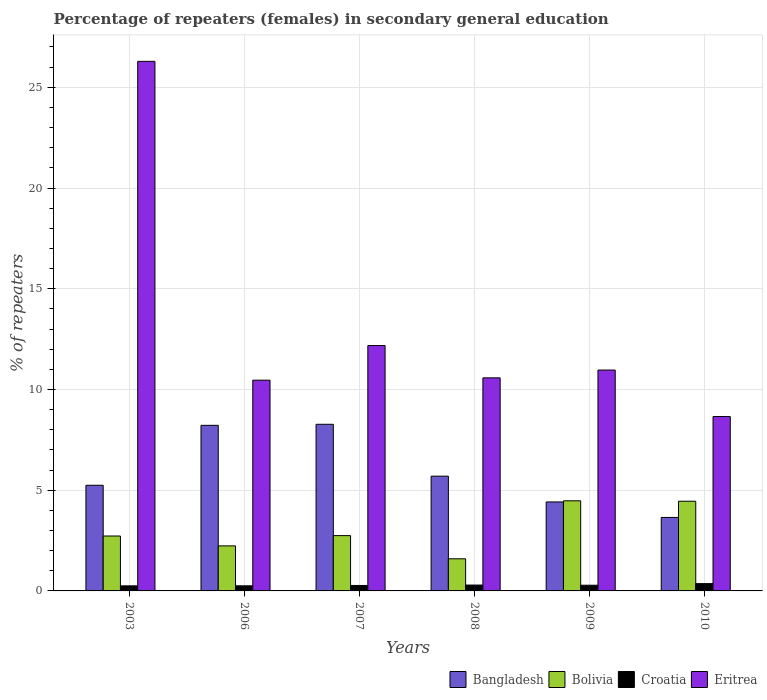How many groups of bars are there?
Keep it short and to the point. 6. Are the number of bars on each tick of the X-axis equal?
Offer a terse response. Yes. What is the label of the 5th group of bars from the left?
Make the answer very short. 2009. What is the percentage of female repeaters in Bolivia in 2009?
Ensure brevity in your answer.  4.47. Across all years, what is the maximum percentage of female repeaters in Croatia?
Keep it short and to the point. 0.36. Across all years, what is the minimum percentage of female repeaters in Croatia?
Provide a succinct answer. 0.25. What is the total percentage of female repeaters in Bolivia in the graph?
Ensure brevity in your answer.  18.23. What is the difference between the percentage of female repeaters in Bolivia in 2006 and that in 2008?
Keep it short and to the point. 0.64. What is the difference between the percentage of female repeaters in Bolivia in 2010 and the percentage of female repeaters in Bangladesh in 2003?
Offer a very short reply. -0.79. What is the average percentage of female repeaters in Bangladesh per year?
Your response must be concise. 5.92. In the year 2006, what is the difference between the percentage of female repeaters in Eritrea and percentage of female repeaters in Bolivia?
Offer a terse response. 8.23. What is the ratio of the percentage of female repeaters in Eritrea in 2008 to that in 2009?
Provide a short and direct response. 0.96. What is the difference between the highest and the second highest percentage of female repeaters in Eritrea?
Offer a very short reply. 14.11. What is the difference between the highest and the lowest percentage of female repeaters in Croatia?
Give a very brief answer. 0.11. Is the sum of the percentage of female repeaters in Bolivia in 2006 and 2009 greater than the maximum percentage of female repeaters in Bangladesh across all years?
Provide a short and direct response. No. What does the 3rd bar from the left in 2009 represents?
Your response must be concise. Croatia. Does the graph contain any zero values?
Your response must be concise. No. How many legend labels are there?
Your response must be concise. 4. How are the legend labels stacked?
Give a very brief answer. Horizontal. What is the title of the graph?
Give a very brief answer. Percentage of repeaters (females) in secondary general education. What is the label or title of the Y-axis?
Provide a short and direct response. % of repeaters. What is the % of repeaters in Bangladesh in 2003?
Your answer should be compact. 5.24. What is the % of repeaters of Bolivia in 2003?
Make the answer very short. 2.73. What is the % of repeaters in Croatia in 2003?
Give a very brief answer. 0.25. What is the % of repeaters in Eritrea in 2003?
Provide a succinct answer. 26.29. What is the % of repeaters of Bangladesh in 2006?
Keep it short and to the point. 8.22. What is the % of repeaters in Bolivia in 2006?
Ensure brevity in your answer.  2.24. What is the % of repeaters in Croatia in 2006?
Your answer should be compact. 0.25. What is the % of repeaters of Eritrea in 2006?
Your answer should be compact. 10.46. What is the % of repeaters of Bangladesh in 2007?
Keep it short and to the point. 8.27. What is the % of repeaters of Bolivia in 2007?
Offer a terse response. 2.75. What is the % of repeaters of Croatia in 2007?
Your answer should be compact. 0.27. What is the % of repeaters in Eritrea in 2007?
Provide a short and direct response. 12.18. What is the % of repeaters of Bangladesh in 2008?
Your answer should be compact. 5.7. What is the % of repeaters in Bolivia in 2008?
Provide a succinct answer. 1.6. What is the % of repeaters in Croatia in 2008?
Ensure brevity in your answer.  0.29. What is the % of repeaters of Eritrea in 2008?
Provide a succinct answer. 10.58. What is the % of repeaters of Bangladesh in 2009?
Offer a terse response. 4.42. What is the % of repeaters in Bolivia in 2009?
Offer a terse response. 4.47. What is the % of repeaters of Croatia in 2009?
Make the answer very short. 0.28. What is the % of repeaters of Eritrea in 2009?
Keep it short and to the point. 10.96. What is the % of repeaters of Bangladesh in 2010?
Provide a succinct answer. 3.65. What is the % of repeaters of Bolivia in 2010?
Your answer should be very brief. 4.45. What is the % of repeaters of Croatia in 2010?
Your answer should be very brief. 0.36. What is the % of repeaters of Eritrea in 2010?
Keep it short and to the point. 8.66. Across all years, what is the maximum % of repeaters in Bangladesh?
Offer a very short reply. 8.27. Across all years, what is the maximum % of repeaters in Bolivia?
Give a very brief answer. 4.47. Across all years, what is the maximum % of repeaters of Croatia?
Your answer should be very brief. 0.36. Across all years, what is the maximum % of repeaters of Eritrea?
Make the answer very short. 26.29. Across all years, what is the minimum % of repeaters of Bangladesh?
Provide a short and direct response. 3.65. Across all years, what is the minimum % of repeaters of Bolivia?
Your response must be concise. 1.6. Across all years, what is the minimum % of repeaters of Croatia?
Keep it short and to the point. 0.25. Across all years, what is the minimum % of repeaters in Eritrea?
Your answer should be very brief. 8.66. What is the total % of repeaters in Bangladesh in the graph?
Ensure brevity in your answer.  35.5. What is the total % of repeaters in Bolivia in the graph?
Keep it short and to the point. 18.23. What is the total % of repeaters in Croatia in the graph?
Ensure brevity in your answer.  1.71. What is the total % of repeaters of Eritrea in the graph?
Give a very brief answer. 79.12. What is the difference between the % of repeaters in Bangladesh in 2003 and that in 2006?
Give a very brief answer. -2.98. What is the difference between the % of repeaters in Bolivia in 2003 and that in 2006?
Your answer should be compact. 0.49. What is the difference between the % of repeaters in Croatia in 2003 and that in 2006?
Your answer should be compact. -0. What is the difference between the % of repeaters in Eritrea in 2003 and that in 2006?
Give a very brief answer. 15.83. What is the difference between the % of repeaters in Bangladesh in 2003 and that in 2007?
Offer a very short reply. -3.03. What is the difference between the % of repeaters of Bolivia in 2003 and that in 2007?
Keep it short and to the point. -0.02. What is the difference between the % of repeaters in Croatia in 2003 and that in 2007?
Keep it short and to the point. -0.02. What is the difference between the % of repeaters of Eritrea in 2003 and that in 2007?
Keep it short and to the point. 14.11. What is the difference between the % of repeaters of Bangladesh in 2003 and that in 2008?
Your answer should be compact. -0.45. What is the difference between the % of repeaters of Bolivia in 2003 and that in 2008?
Give a very brief answer. 1.13. What is the difference between the % of repeaters of Croatia in 2003 and that in 2008?
Your response must be concise. -0.04. What is the difference between the % of repeaters in Eritrea in 2003 and that in 2008?
Offer a terse response. 15.71. What is the difference between the % of repeaters of Bangladesh in 2003 and that in 2009?
Offer a very short reply. 0.83. What is the difference between the % of repeaters in Bolivia in 2003 and that in 2009?
Make the answer very short. -1.75. What is the difference between the % of repeaters in Croatia in 2003 and that in 2009?
Your response must be concise. -0.03. What is the difference between the % of repeaters in Eritrea in 2003 and that in 2009?
Provide a succinct answer. 15.32. What is the difference between the % of repeaters of Bangladesh in 2003 and that in 2010?
Ensure brevity in your answer.  1.6. What is the difference between the % of repeaters of Bolivia in 2003 and that in 2010?
Keep it short and to the point. -1.73. What is the difference between the % of repeaters in Croatia in 2003 and that in 2010?
Provide a short and direct response. -0.11. What is the difference between the % of repeaters in Eritrea in 2003 and that in 2010?
Your answer should be compact. 17.63. What is the difference between the % of repeaters of Bangladesh in 2006 and that in 2007?
Make the answer very short. -0.05. What is the difference between the % of repeaters in Bolivia in 2006 and that in 2007?
Your response must be concise. -0.51. What is the difference between the % of repeaters of Croatia in 2006 and that in 2007?
Ensure brevity in your answer.  -0.02. What is the difference between the % of repeaters in Eritrea in 2006 and that in 2007?
Your response must be concise. -1.72. What is the difference between the % of repeaters of Bangladesh in 2006 and that in 2008?
Your answer should be compact. 2.52. What is the difference between the % of repeaters in Bolivia in 2006 and that in 2008?
Offer a terse response. 0.64. What is the difference between the % of repeaters in Croatia in 2006 and that in 2008?
Offer a very short reply. -0.04. What is the difference between the % of repeaters in Eritrea in 2006 and that in 2008?
Ensure brevity in your answer.  -0.11. What is the difference between the % of repeaters of Bangladesh in 2006 and that in 2009?
Your response must be concise. 3.8. What is the difference between the % of repeaters in Bolivia in 2006 and that in 2009?
Provide a succinct answer. -2.24. What is the difference between the % of repeaters in Croatia in 2006 and that in 2009?
Ensure brevity in your answer.  -0.03. What is the difference between the % of repeaters of Eritrea in 2006 and that in 2009?
Your answer should be very brief. -0.5. What is the difference between the % of repeaters in Bangladesh in 2006 and that in 2010?
Keep it short and to the point. 4.57. What is the difference between the % of repeaters of Bolivia in 2006 and that in 2010?
Offer a very short reply. -2.22. What is the difference between the % of repeaters of Croatia in 2006 and that in 2010?
Give a very brief answer. -0.11. What is the difference between the % of repeaters in Eritrea in 2006 and that in 2010?
Your answer should be compact. 1.8. What is the difference between the % of repeaters of Bangladesh in 2007 and that in 2008?
Make the answer very short. 2.57. What is the difference between the % of repeaters in Bolivia in 2007 and that in 2008?
Your answer should be compact. 1.15. What is the difference between the % of repeaters in Croatia in 2007 and that in 2008?
Your answer should be very brief. -0.02. What is the difference between the % of repeaters in Eritrea in 2007 and that in 2008?
Make the answer very short. 1.6. What is the difference between the % of repeaters in Bangladesh in 2007 and that in 2009?
Offer a terse response. 3.85. What is the difference between the % of repeaters in Bolivia in 2007 and that in 2009?
Ensure brevity in your answer.  -1.73. What is the difference between the % of repeaters of Croatia in 2007 and that in 2009?
Your response must be concise. -0.01. What is the difference between the % of repeaters of Eritrea in 2007 and that in 2009?
Keep it short and to the point. 1.22. What is the difference between the % of repeaters in Bangladesh in 2007 and that in 2010?
Ensure brevity in your answer.  4.62. What is the difference between the % of repeaters in Bolivia in 2007 and that in 2010?
Provide a short and direct response. -1.71. What is the difference between the % of repeaters in Croatia in 2007 and that in 2010?
Ensure brevity in your answer.  -0.09. What is the difference between the % of repeaters in Eritrea in 2007 and that in 2010?
Give a very brief answer. 3.52. What is the difference between the % of repeaters of Bangladesh in 2008 and that in 2009?
Offer a very short reply. 1.28. What is the difference between the % of repeaters of Bolivia in 2008 and that in 2009?
Provide a succinct answer. -2.88. What is the difference between the % of repeaters in Croatia in 2008 and that in 2009?
Your answer should be very brief. 0.01. What is the difference between the % of repeaters in Eritrea in 2008 and that in 2009?
Your answer should be compact. -0.39. What is the difference between the % of repeaters in Bangladesh in 2008 and that in 2010?
Your answer should be very brief. 2.05. What is the difference between the % of repeaters in Bolivia in 2008 and that in 2010?
Offer a terse response. -2.86. What is the difference between the % of repeaters of Croatia in 2008 and that in 2010?
Your answer should be compact. -0.07. What is the difference between the % of repeaters of Eritrea in 2008 and that in 2010?
Keep it short and to the point. 1.92. What is the difference between the % of repeaters in Bangladesh in 2009 and that in 2010?
Ensure brevity in your answer.  0.77. What is the difference between the % of repeaters of Bolivia in 2009 and that in 2010?
Offer a terse response. 0.02. What is the difference between the % of repeaters of Croatia in 2009 and that in 2010?
Provide a short and direct response. -0.08. What is the difference between the % of repeaters in Eritrea in 2009 and that in 2010?
Provide a succinct answer. 2.31. What is the difference between the % of repeaters in Bangladesh in 2003 and the % of repeaters in Bolivia in 2006?
Give a very brief answer. 3.01. What is the difference between the % of repeaters in Bangladesh in 2003 and the % of repeaters in Croatia in 2006?
Offer a very short reply. 4.99. What is the difference between the % of repeaters of Bangladesh in 2003 and the % of repeaters of Eritrea in 2006?
Provide a short and direct response. -5.22. What is the difference between the % of repeaters in Bolivia in 2003 and the % of repeaters in Croatia in 2006?
Offer a very short reply. 2.47. What is the difference between the % of repeaters of Bolivia in 2003 and the % of repeaters of Eritrea in 2006?
Make the answer very short. -7.74. What is the difference between the % of repeaters of Croatia in 2003 and the % of repeaters of Eritrea in 2006?
Keep it short and to the point. -10.21. What is the difference between the % of repeaters of Bangladesh in 2003 and the % of repeaters of Bolivia in 2007?
Provide a succinct answer. 2.5. What is the difference between the % of repeaters of Bangladesh in 2003 and the % of repeaters of Croatia in 2007?
Keep it short and to the point. 4.97. What is the difference between the % of repeaters in Bangladesh in 2003 and the % of repeaters in Eritrea in 2007?
Give a very brief answer. -6.93. What is the difference between the % of repeaters in Bolivia in 2003 and the % of repeaters in Croatia in 2007?
Your response must be concise. 2.45. What is the difference between the % of repeaters of Bolivia in 2003 and the % of repeaters of Eritrea in 2007?
Offer a terse response. -9.45. What is the difference between the % of repeaters in Croatia in 2003 and the % of repeaters in Eritrea in 2007?
Your answer should be very brief. -11.93. What is the difference between the % of repeaters of Bangladesh in 2003 and the % of repeaters of Bolivia in 2008?
Your answer should be very brief. 3.65. What is the difference between the % of repeaters of Bangladesh in 2003 and the % of repeaters of Croatia in 2008?
Ensure brevity in your answer.  4.95. What is the difference between the % of repeaters of Bangladesh in 2003 and the % of repeaters of Eritrea in 2008?
Keep it short and to the point. -5.33. What is the difference between the % of repeaters in Bolivia in 2003 and the % of repeaters in Croatia in 2008?
Your response must be concise. 2.43. What is the difference between the % of repeaters in Bolivia in 2003 and the % of repeaters in Eritrea in 2008?
Ensure brevity in your answer.  -7.85. What is the difference between the % of repeaters of Croatia in 2003 and the % of repeaters of Eritrea in 2008?
Offer a very short reply. -10.32. What is the difference between the % of repeaters of Bangladesh in 2003 and the % of repeaters of Bolivia in 2009?
Give a very brief answer. 0.77. What is the difference between the % of repeaters in Bangladesh in 2003 and the % of repeaters in Croatia in 2009?
Give a very brief answer. 4.96. What is the difference between the % of repeaters in Bangladesh in 2003 and the % of repeaters in Eritrea in 2009?
Provide a succinct answer. -5.72. What is the difference between the % of repeaters of Bolivia in 2003 and the % of repeaters of Croatia in 2009?
Offer a very short reply. 2.44. What is the difference between the % of repeaters in Bolivia in 2003 and the % of repeaters in Eritrea in 2009?
Your answer should be very brief. -8.24. What is the difference between the % of repeaters of Croatia in 2003 and the % of repeaters of Eritrea in 2009?
Your answer should be compact. -10.71. What is the difference between the % of repeaters of Bangladesh in 2003 and the % of repeaters of Bolivia in 2010?
Your answer should be very brief. 0.79. What is the difference between the % of repeaters of Bangladesh in 2003 and the % of repeaters of Croatia in 2010?
Provide a short and direct response. 4.88. What is the difference between the % of repeaters of Bangladesh in 2003 and the % of repeaters of Eritrea in 2010?
Your response must be concise. -3.41. What is the difference between the % of repeaters of Bolivia in 2003 and the % of repeaters of Croatia in 2010?
Ensure brevity in your answer.  2.36. What is the difference between the % of repeaters of Bolivia in 2003 and the % of repeaters of Eritrea in 2010?
Offer a terse response. -5.93. What is the difference between the % of repeaters in Croatia in 2003 and the % of repeaters in Eritrea in 2010?
Give a very brief answer. -8.41. What is the difference between the % of repeaters of Bangladesh in 2006 and the % of repeaters of Bolivia in 2007?
Your answer should be very brief. 5.47. What is the difference between the % of repeaters in Bangladesh in 2006 and the % of repeaters in Croatia in 2007?
Offer a terse response. 7.95. What is the difference between the % of repeaters in Bangladesh in 2006 and the % of repeaters in Eritrea in 2007?
Keep it short and to the point. -3.96. What is the difference between the % of repeaters in Bolivia in 2006 and the % of repeaters in Croatia in 2007?
Provide a succinct answer. 1.96. What is the difference between the % of repeaters of Bolivia in 2006 and the % of repeaters of Eritrea in 2007?
Provide a succinct answer. -9.94. What is the difference between the % of repeaters of Croatia in 2006 and the % of repeaters of Eritrea in 2007?
Make the answer very short. -11.93. What is the difference between the % of repeaters of Bangladesh in 2006 and the % of repeaters of Bolivia in 2008?
Make the answer very short. 6.62. What is the difference between the % of repeaters of Bangladesh in 2006 and the % of repeaters of Croatia in 2008?
Keep it short and to the point. 7.93. What is the difference between the % of repeaters of Bangladesh in 2006 and the % of repeaters of Eritrea in 2008?
Ensure brevity in your answer.  -2.36. What is the difference between the % of repeaters of Bolivia in 2006 and the % of repeaters of Croatia in 2008?
Keep it short and to the point. 1.94. What is the difference between the % of repeaters in Bolivia in 2006 and the % of repeaters in Eritrea in 2008?
Your answer should be compact. -8.34. What is the difference between the % of repeaters in Croatia in 2006 and the % of repeaters in Eritrea in 2008?
Ensure brevity in your answer.  -10.32. What is the difference between the % of repeaters of Bangladesh in 2006 and the % of repeaters of Bolivia in 2009?
Your answer should be very brief. 3.75. What is the difference between the % of repeaters in Bangladesh in 2006 and the % of repeaters in Croatia in 2009?
Offer a very short reply. 7.94. What is the difference between the % of repeaters in Bangladesh in 2006 and the % of repeaters in Eritrea in 2009?
Provide a short and direct response. -2.74. What is the difference between the % of repeaters of Bolivia in 2006 and the % of repeaters of Croatia in 2009?
Ensure brevity in your answer.  1.95. What is the difference between the % of repeaters in Bolivia in 2006 and the % of repeaters in Eritrea in 2009?
Make the answer very short. -8.73. What is the difference between the % of repeaters in Croatia in 2006 and the % of repeaters in Eritrea in 2009?
Offer a very short reply. -10.71. What is the difference between the % of repeaters in Bangladesh in 2006 and the % of repeaters in Bolivia in 2010?
Provide a succinct answer. 3.77. What is the difference between the % of repeaters in Bangladesh in 2006 and the % of repeaters in Croatia in 2010?
Ensure brevity in your answer.  7.86. What is the difference between the % of repeaters of Bangladesh in 2006 and the % of repeaters of Eritrea in 2010?
Provide a short and direct response. -0.44. What is the difference between the % of repeaters in Bolivia in 2006 and the % of repeaters in Croatia in 2010?
Make the answer very short. 1.87. What is the difference between the % of repeaters in Bolivia in 2006 and the % of repeaters in Eritrea in 2010?
Your answer should be compact. -6.42. What is the difference between the % of repeaters of Croatia in 2006 and the % of repeaters of Eritrea in 2010?
Ensure brevity in your answer.  -8.4. What is the difference between the % of repeaters of Bangladesh in 2007 and the % of repeaters of Bolivia in 2008?
Give a very brief answer. 6.68. What is the difference between the % of repeaters in Bangladesh in 2007 and the % of repeaters in Croatia in 2008?
Your response must be concise. 7.98. What is the difference between the % of repeaters in Bangladesh in 2007 and the % of repeaters in Eritrea in 2008?
Offer a terse response. -2.3. What is the difference between the % of repeaters of Bolivia in 2007 and the % of repeaters of Croatia in 2008?
Your answer should be very brief. 2.45. What is the difference between the % of repeaters of Bolivia in 2007 and the % of repeaters of Eritrea in 2008?
Your answer should be very brief. -7.83. What is the difference between the % of repeaters of Croatia in 2007 and the % of repeaters of Eritrea in 2008?
Your response must be concise. -10.31. What is the difference between the % of repeaters of Bangladesh in 2007 and the % of repeaters of Bolivia in 2009?
Ensure brevity in your answer.  3.8. What is the difference between the % of repeaters of Bangladesh in 2007 and the % of repeaters of Croatia in 2009?
Provide a short and direct response. 7.99. What is the difference between the % of repeaters of Bangladesh in 2007 and the % of repeaters of Eritrea in 2009?
Give a very brief answer. -2.69. What is the difference between the % of repeaters in Bolivia in 2007 and the % of repeaters in Croatia in 2009?
Provide a short and direct response. 2.46. What is the difference between the % of repeaters in Bolivia in 2007 and the % of repeaters in Eritrea in 2009?
Offer a very short reply. -8.22. What is the difference between the % of repeaters in Croatia in 2007 and the % of repeaters in Eritrea in 2009?
Keep it short and to the point. -10.69. What is the difference between the % of repeaters of Bangladesh in 2007 and the % of repeaters of Bolivia in 2010?
Your answer should be compact. 3.82. What is the difference between the % of repeaters in Bangladesh in 2007 and the % of repeaters in Croatia in 2010?
Your response must be concise. 7.91. What is the difference between the % of repeaters in Bangladesh in 2007 and the % of repeaters in Eritrea in 2010?
Your response must be concise. -0.39. What is the difference between the % of repeaters of Bolivia in 2007 and the % of repeaters of Croatia in 2010?
Your answer should be compact. 2.38. What is the difference between the % of repeaters in Bolivia in 2007 and the % of repeaters in Eritrea in 2010?
Provide a short and direct response. -5.91. What is the difference between the % of repeaters in Croatia in 2007 and the % of repeaters in Eritrea in 2010?
Provide a short and direct response. -8.39. What is the difference between the % of repeaters in Bangladesh in 2008 and the % of repeaters in Bolivia in 2009?
Give a very brief answer. 1.22. What is the difference between the % of repeaters of Bangladesh in 2008 and the % of repeaters of Croatia in 2009?
Provide a short and direct response. 5.41. What is the difference between the % of repeaters of Bangladesh in 2008 and the % of repeaters of Eritrea in 2009?
Make the answer very short. -5.27. What is the difference between the % of repeaters of Bolivia in 2008 and the % of repeaters of Croatia in 2009?
Give a very brief answer. 1.31. What is the difference between the % of repeaters in Bolivia in 2008 and the % of repeaters in Eritrea in 2009?
Your answer should be compact. -9.37. What is the difference between the % of repeaters in Croatia in 2008 and the % of repeaters in Eritrea in 2009?
Your response must be concise. -10.67. What is the difference between the % of repeaters in Bangladesh in 2008 and the % of repeaters in Bolivia in 2010?
Offer a terse response. 1.24. What is the difference between the % of repeaters in Bangladesh in 2008 and the % of repeaters in Croatia in 2010?
Your response must be concise. 5.33. What is the difference between the % of repeaters in Bangladesh in 2008 and the % of repeaters in Eritrea in 2010?
Provide a short and direct response. -2.96. What is the difference between the % of repeaters of Bolivia in 2008 and the % of repeaters of Croatia in 2010?
Give a very brief answer. 1.23. What is the difference between the % of repeaters in Bolivia in 2008 and the % of repeaters in Eritrea in 2010?
Your answer should be very brief. -7.06. What is the difference between the % of repeaters of Croatia in 2008 and the % of repeaters of Eritrea in 2010?
Provide a succinct answer. -8.37. What is the difference between the % of repeaters in Bangladesh in 2009 and the % of repeaters in Bolivia in 2010?
Your answer should be very brief. -0.04. What is the difference between the % of repeaters in Bangladesh in 2009 and the % of repeaters in Croatia in 2010?
Your answer should be compact. 4.05. What is the difference between the % of repeaters in Bangladesh in 2009 and the % of repeaters in Eritrea in 2010?
Make the answer very short. -4.24. What is the difference between the % of repeaters of Bolivia in 2009 and the % of repeaters of Croatia in 2010?
Give a very brief answer. 4.11. What is the difference between the % of repeaters in Bolivia in 2009 and the % of repeaters in Eritrea in 2010?
Your answer should be very brief. -4.18. What is the difference between the % of repeaters in Croatia in 2009 and the % of repeaters in Eritrea in 2010?
Provide a succinct answer. -8.37. What is the average % of repeaters in Bangladesh per year?
Make the answer very short. 5.92. What is the average % of repeaters in Bolivia per year?
Provide a succinct answer. 3.04. What is the average % of repeaters in Croatia per year?
Keep it short and to the point. 0.29. What is the average % of repeaters in Eritrea per year?
Provide a short and direct response. 13.19. In the year 2003, what is the difference between the % of repeaters of Bangladesh and % of repeaters of Bolivia?
Your answer should be compact. 2.52. In the year 2003, what is the difference between the % of repeaters of Bangladesh and % of repeaters of Croatia?
Your answer should be very brief. 4.99. In the year 2003, what is the difference between the % of repeaters of Bangladesh and % of repeaters of Eritrea?
Provide a succinct answer. -21.04. In the year 2003, what is the difference between the % of repeaters of Bolivia and % of repeaters of Croatia?
Your response must be concise. 2.47. In the year 2003, what is the difference between the % of repeaters of Bolivia and % of repeaters of Eritrea?
Provide a short and direct response. -23.56. In the year 2003, what is the difference between the % of repeaters of Croatia and % of repeaters of Eritrea?
Offer a terse response. -26.04. In the year 2006, what is the difference between the % of repeaters in Bangladesh and % of repeaters in Bolivia?
Provide a succinct answer. 5.98. In the year 2006, what is the difference between the % of repeaters in Bangladesh and % of repeaters in Croatia?
Provide a short and direct response. 7.97. In the year 2006, what is the difference between the % of repeaters in Bangladesh and % of repeaters in Eritrea?
Make the answer very short. -2.24. In the year 2006, what is the difference between the % of repeaters of Bolivia and % of repeaters of Croatia?
Your answer should be compact. 1.98. In the year 2006, what is the difference between the % of repeaters in Bolivia and % of repeaters in Eritrea?
Ensure brevity in your answer.  -8.23. In the year 2006, what is the difference between the % of repeaters in Croatia and % of repeaters in Eritrea?
Give a very brief answer. -10.21. In the year 2007, what is the difference between the % of repeaters in Bangladesh and % of repeaters in Bolivia?
Make the answer very short. 5.53. In the year 2007, what is the difference between the % of repeaters in Bangladesh and % of repeaters in Croatia?
Your answer should be compact. 8. In the year 2007, what is the difference between the % of repeaters in Bangladesh and % of repeaters in Eritrea?
Your response must be concise. -3.91. In the year 2007, what is the difference between the % of repeaters of Bolivia and % of repeaters of Croatia?
Make the answer very short. 2.47. In the year 2007, what is the difference between the % of repeaters in Bolivia and % of repeaters in Eritrea?
Provide a succinct answer. -9.43. In the year 2007, what is the difference between the % of repeaters in Croatia and % of repeaters in Eritrea?
Make the answer very short. -11.91. In the year 2008, what is the difference between the % of repeaters of Bangladesh and % of repeaters of Bolivia?
Your answer should be very brief. 4.1. In the year 2008, what is the difference between the % of repeaters of Bangladesh and % of repeaters of Croatia?
Ensure brevity in your answer.  5.41. In the year 2008, what is the difference between the % of repeaters in Bangladesh and % of repeaters in Eritrea?
Make the answer very short. -4.88. In the year 2008, what is the difference between the % of repeaters in Bolivia and % of repeaters in Croatia?
Make the answer very short. 1.3. In the year 2008, what is the difference between the % of repeaters of Bolivia and % of repeaters of Eritrea?
Ensure brevity in your answer.  -8.98. In the year 2008, what is the difference between the % of repeaters in Croatia and % of repeaters in Eritrea?
Keep it short and to the point. -10.29. In the year 2009, what is the difference between the % of repeaters in Bangladesh and % of repeaters in Bolivia?
Ensure brevity in your answer.  -0.06. In the year 2009, what is the difference between the % of repeaters of Bangladesh and % of repeaters of Croatia?
Ensure brevity in your answer.  4.13. In the year 2009, what is the difference between the % of repeaters of Bangladesh and % of repeaters of Eritrea?
Ensure brevity in your answer.  -6.55. In the year 2009, what is the difference between the % of repeaters in Bolivia and % of repeaters in Croatia?
Your answer should be very brief. 4.19. In the year 2009, what is the difference between the % of repeaters in Bolivia and % of repeaters in Eritrea?
Your response must be concise. -6.49. In the year 2009, what is the difference between the % of repeaters of Croatia and % of repeaters of Eritrea?
Make the answer very short. -10.68. In the year 2010, what is the difference between the % of repeaters of Bangladesh and % of repeaters of Bolivia?
Ensure brevity in your answer.  -0.81. In the year 2010, what is the difference between the % of repeaters of Bangladesh and % of repeaters of Croatia?
Ensure brevity in your answer.  3.29. In the year 2010, what is the difference between the % of repeaters of Bangladesh and % of repeaters of Eritrea?
Make the answer very short. -5.01. In the year 2010, what is the difference between the % of repeaters of Bolivia and % of repeaters of Croatia?
Your answer should be compact. 4.09. In the year 2010, what is the difference between the % of repeaters in Bolivia and % of repeaters in Eritrea?
Provide a succinct answer. -4.2. In the year 2010, what is the difference between the % of repeaters in Croatia and % of repeaters in Eritrea?
Provide a succinct answer. -8.29. What is the ratio of the % of repeaters in Bangladesh in 2003 to that in 2006?
Ensure brevity in your answer.  0.64. What is the ratio of the % of repeaters in Bolivia in 2003 to that in 2006?
Provide a short and direct response. 1.22. What is the ratio of the % of repeaters of Croatia in 2003 to that in 2006?
Offer a very short reply. 0.99. What is the ratio of the % of repeaters of Eritrea in 2003 to that in 2006?
Give a very brief answer. 2.51. What is the ratio of the % of repeaters of Bangladesh in 2003 to that in 2007?
Your answer should be very brief. 0.63. What is the ratio of the % of repeaters in Bolivia in 2003 to that in 2007?
Give a very brief answer. 0.99. What is the ratio of the % of repeaters in Croatia in 2003 to that in 2007?
Your answer should be compact. 0.93. What is the ratio of the % of repeaters of Eritrea in 2003 to that in 2007?
Your answer should be compact. 2.16. What is the ratio of the % of repeaters in Bangladesh in 2003 to that in 2008?
Offer a very short reply. 0.92. What is the ratio of the % of repeaters in Bolivia in 2003 to that in 2008?
Ensure brevity in your answer.  1.71. What is the ratio of the % of repeaters of Croatia in 2003 to that in 2008?
Provide a short and direct response. 0.86. What is the ratio of the % of repeaters in Eritrea in 2003 to that in 2008?
Provide a succinct answer. 2.49. What is the ratio of the % of repeaters of Bangladesh in 2003 to that in 2009?
Offer a very short reply. 1.19. What is the ratio of the % of repeaters in Bolivia in 2003 to that in 2009?
Offer a terse response. 0.61. What is the ratio of the % of repeaters of Croatia in 2003 to that in 2009?
Offer a very short reply. 0.89. What is the ratio of the % of repeaters of Eritrea in 2003 to that in 2009?
Offer a very short reply. 2.4. What is the ratio of the % of repeaters in Bangladesh in 2003 to that in 2010?
Your response must be concise. 1.44. What is the ratio of the % of repeaters of Bolivia in 2003 to that in 2010?
Your answer should be compact. 0.61. What is the ratio of the % of repeaters in Croatia in 2003 to that in 2010?
Provide a short and direct response. 0.69. What is the ratio of the % of repeaters in Eritrea in 2003 to that in 2010?
Provide a succinct answer. 3.04. What is the ratio of the % of repeaters of Bangladesh in 2006 to that in 2007?
Your answer should be compact. 0.99. What is the ratio of the % of repeaters of Bolivia in 2006 to that in 2007?
Offer a very short reply. 0.81. What is the ratio of the % of repeaters in Croatia in 2006 to that in 2007?
Your answer should be compact. 0.94. What is the ratio of the % of repeaters of Eritrea in 2006 to that in 2007?
Provide a short and direct response. 0.86. What is the ratio of the % of repeaters in Bangladesh in 2006 to that in 2008?
Your response must be concise. 1.44. What is the ratio of the % of repeaters in Bolivia in 2006 to that in 2008?
Ensure brevity in your answer.  1.4. What is the ratio of the % of repeaters in Croatia in 2006 to that in 2008?
Your response must be concise. 0.87. What is the ratio of the % of repeaters of Bangladesh in 2006 to that in 2009?
Give a very brief answer. 1.86. What is the ratio of the % of repeaters of Bolivia in 2006 to that in 2009?
Make the answer very short. 0.5. What is the ratio of the % of repeaters of Croatia in 2006 to that in 2009?
Give a very brief answer. 0.9. What is the ratio of the % of repeaters of Eritrea in 2006 to that in 2009?
Give a very brief answer. 0.95. What is the ratio of the % of repeaters of Bangladesh in 2006 to that in 2010?
Ensure brevity in your answer.  2.25. What is the ratio of the % of repeaters of Bolivia in 2006 to that in 2010?
Ensure brevity in your answer.  0.5. What is the ratio of the % of repeaters of Croatia in 2006 to that in 2010?
Your answer should be compact. 0.7. What is the ratio of the % of repeaters in Eritrea in 2006 to that in 2010?
Keep it short and to the point. 1.21. What is the ratio of the % of repeaters in Bangladesh in 2007 to that in 2008?
Offer a very short reply. 1.45. What is the ratio of the % of repeaters of Bolivia in 2007 to that in 2008?
Offer a very short reply. 1.72. What is the ratio of the % of repeaters of Croatia in 2007 to that in 2008?
Your answer should be compact. 0.93. What is the ratio of the % of repeaters in Eritrea in 2007 to that in 2008?
Offer a very short reply. 1.15. What is the ratio of the % of repeaters of Bangladesh in 2007 to that in 2009?
Offer a terse response. 1.87. What is the ratio of the % of repeaters of Bolivia in 2007 to that in 2009?
Offer a terse response. 0.61. What is the ratio of the % of repeaters in Croatia in 2007 to that in 2009?
Offer a terse response. 0.96. What is the ratio of the % of repeaters of Eritrea in 2007 to that in 2009?
Offer a terse response. 1.11. What is the ratio of the % of repeaters of Bangladesh in 2007 to that in 2010?
Offer a very short reply. 2.27. What is the ratio of the % of repeaters of Bolivia in 2007 to that in 2010?
Provide a succinct answer. 0.62. What is the ratio of the % of repeaters in Croatia in 2007 to that in 2010?
Keep it short and to the point. 0.75. What is the ratio of the % of repeaters in Eritrea in 2007 to that in 2010?
Ensure brevity in your answer.  1.41. What is the ratio of the % of repeaters in Bangladesh in 2008 to that in 2009?
Make the answer very short. 1.29. What is the ratio of the % of repeaters in Bolivia in 2008 to that in 2009?
Provide a short and direct response. 0.36. What is the ratio of the % of repeaters of Croatia in 2008 to that in 2009?
Offer a very short reply. 1.03. What is the ratio of the % of repeaters in Eritrea in 2008 to that in 2009?
Make the answer very short. 0.96. What is the ratio of the % of repeaters of Bangladesh in 2008 to that in 2010?
Keep it short and to the point. 1.56. What is the ratio of the % of repeaters in Bolivia in 2008 to that in 2010?
Your answer should be very brief. 0.36. What is the ratio of the % of repeaters in Croatia in 2008 to that in 2010?
Your answer should be compact. 0.8. What is the ratio of the % of repeaters in Eritrea in 2008 to that in 2010?
Make the answer very short. 1.22. What is the ratio of the % of repeaters in Bangladesh in 2009 to that in 2010?
Offer a very short reply. 1.21. What is the ratio of the % of repeaters in Bolivia in 2009 to that in 2010?
Provide a succinct answer. 1. What is the ratio of the % of repeaters of Croatia in 2009 to that in 2010?
Your response must be concise. 0.78. What is the ratio of the % of repeaters of Eritrea in 2009 to that in 2010?
Offer a very short reply. 1.27. What is the difference between the highest and the second highest % of repeaters in Bangladesh?
Your response must be concise. 0.05. What is the difference between the highest and the second highest % of repeaters in Bolivia?
Offer a very short reply. 0.02. What is the difference between the highest and the second highest % of repeaters in Croatia?
Your response must be concise. 0.07. What is the difference between the highest and the second highest % of repeaters of Eritrea?
Ensure brevity in your answer.  14.11. What is the difference between the highest and the lowest % of repeaters in Bangladesh?
Your response must be concise. 4.62. What is the difference between the highest and the lowest % of repeaters of Bolivia?
Ensure brevity in your answer.  2.88. What is the difference between the highest and the lowest % of repeaters in Croatia?
Give a very brief answer. 0.11. What is the difference between the highest and the lowest % of repeaters of Eritrea?
Provide a short and direct response. 17.63. 